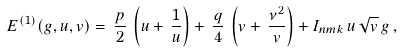<formula> <loc_0><loc_0><loc_500><loc_500>E ^ { ( 1 ) } ( g , u , v ) = \, \frac { p } { 2 } \, \left ( u + \, \frac { 1 } { u } \right ) + \, \frac { q } { 4 } \, \left ( v + \, \frac { \nu ^ { 2 } } { v } \right ) + I _ { n m k } \, u \, \sqrt { v } \, g \, ,</formula> 